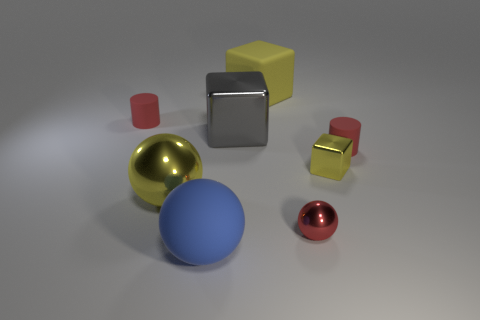The objects in the image have different colors and finishes. Can you describe the differences between their surfaces? Certainly. The scene shows a variety of objects exhibiting different colors and surface qualities. The metallic objects, such as the gold and red spheres, have shiny, reflective surfaces. On the other hand, the blue sphere and the yellow and red blocks have matte finishes, indicative of non-metallic materials like plastic or painted surfaces. 